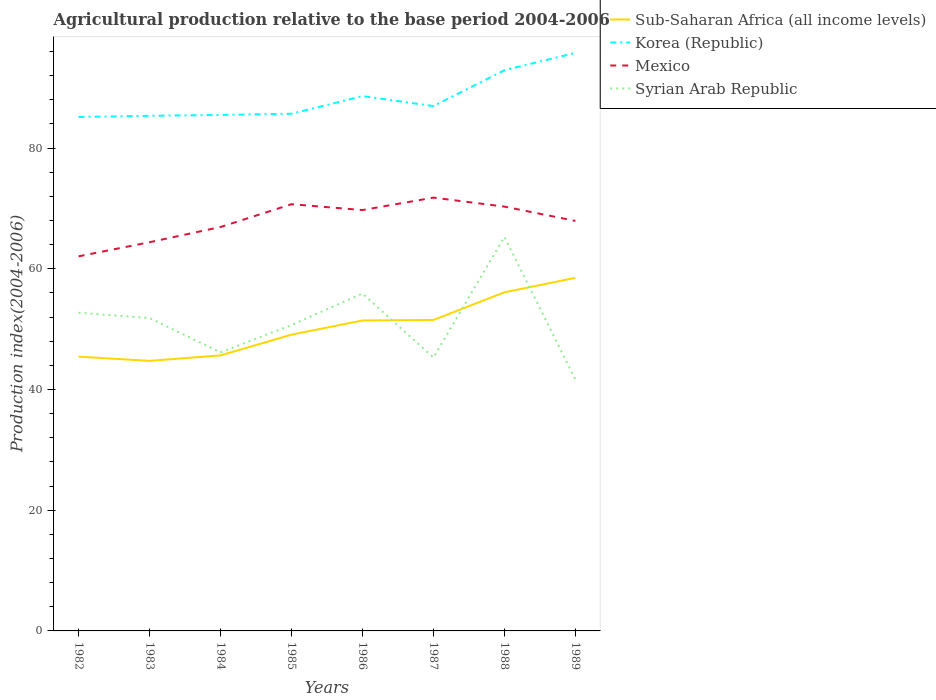Is the number of lines equal to the number of legend labels?
Provide a short and direct response. Yes. Across all years, what is the maximum agricultural production index in Sub-Saharan Africa (all income levels)?
Make the answer very short. 44.75. What is the total agricultural production index in Syrian Arab Republic in the graph?
Your response must be concise. -3.19. What is the difference between the highest and the second highest agricultural production index in Mexico?
Your answer should be compact. 9.73. How many lines are there?
Provide a short and direct response. 4. Does the graph contain any zero values?
Offer a terse response. No. Does the graph contain grids?
Provide a short and direct response. No. How are the legend labels stacked?
Make the answer very short. Vertical. What is the title of the graph?
Provide a short and direct response. Agricultural production relative to the base period 2004-2006. What is the label or title of the Y-axis?
Your answer should be compact. Production index(2004-2006). What is the Production index(2004-2006) in Sub-Saharan Africa (all income levels) in 1982?
Offer a very short reply. 45.45. What is the Production index(2004-2006) of Korea (Republic) in 1982?
Keep it short and to the point. 85.16. What is the Production index(2004-2006) of Mexico in 1982?
Your answer should be very brief. 62.07. What is the Production index(2004-2006) of Syrian Arab Republic in 1982?
Make the answer very short. 52.72. What is the Production index(2004-2006) in Sub-Saharan Africa (all income levels) in 1983?
Your answer should be compact. 44.75. What is the Production index(2004-2006) in Korea (Republic) in 1983?
Provide a succinct answer. 85.36. What is the Production index(2004-2006) in Mexico in 1983?
Provide a short and direct response. 64.41. What is the Production index(2004-2006) of Syrian Arab Republic in 1983?
Offer a terse response. 51.85. What is the Production index(2004-2006) of Sub-Saharan Africa (all income levels) in 1984?
Keep it short and to the point. 45.66. What is the Production index(2004-2006) of Korea (Republic) in 1984?
Your response must be concise. 85.5. What is the Production index(2004-2006) in Mexico in 1984?
Provide a short and direct response. 66.93. What is the Production index(2004-2006) in Syrian Arab Republic in 1984?
Your answer should be very brief. 46.16. What is the Production index(2004-2006) in Sub-Saharan Africa (all income levels) in 1985?
Your answer should be compact. 49.09. What is the Production index(2004-2006) in Korea (Republic) in 1985?
Make the answer very short. 85.7. What is the Production index(2004-2006) in Mexico in 1985?
Offer a terse response. 70.71. What is the Production index(2004-2006) of Syrian Arab Republic in 1985?
Your answer should be compact. 50.69. What is the Production index(2004-2006) of Sub-Saharan Africa (all income levels) in 1986?
Your answer should be compact. 51.44. What is the Production index(2004-2006) of Korea (Republic) in 1986?
Provide a short and direct response. 88.62. What is the Production index(2004-2006) in Mexico in 1986?
Your response must be concise. 69.74. What is the Production index(2004-2006) in Syrian Arab Republic in 1986?
Offer a very short reply. 55.91. What is the Production index(2004-2006) in Sub-Saharan Africa (all income levels) in 1987?
Offer a very short reply. 51.53. What is the Production index(2004-2006) in Korea (Republic) in 1987?
Provide a succinct answer. 86.97. What is the Production index(2004-2006) in Mexico in 1987?
Offer a very short reply. 71.8. What is the Production index(2004-2006) of Syrian Arab Republic in 1987?
Ensure brevity in your answer.  45.3. What is the Production index(2004-2006) of Sub-Saharan Africa (all income levels) in 1988?
Your response must be concise. 56.11. What is the Production index(2004-2006) of Korea (Republic) in 1988?
Offer a terse response. 92.91. What is the Production index(2004-2006) in Mexico in 1988?
Your answer should be compact. 70.31. What is the Production index(2004-2006) of Syrian Arab Republic in 1988?
Give a very brief answer. 65.29. What is the Production index(2004-2006) of Sub-Saharan Africa (all income levels) in 1989?
Provide a short and direct response. 58.51. What is the Production index(2004-2006) of Korea (Republic) in 1989?
Your answer should be compact. 95.78. What is the Production index(2004-2006) of Mexico in 1989?
Offer a very short reply. 67.94. What is the Production index(2004-2006) in Syrian Arab Republic in 1989?
Your answer should be very brief. 41.65. Across all years, what is the maximum Production index(2004-2006) of Sub-Saharan Africa (all income levels)?
Provide a short and direct response. 58.51. Across all years, what is the maximum Production index(2004-2006) of Korea (Republic)?
Give a very brief answer. 95.78. Across all years, what is the maximum Production index(2004-2006) in Mexico?
Provide a short and direct response. 71.8. Across all years, what is the maximum Production index(2004-2006) of Syrian Arab Republic?
Your response must be concise. 65.29. Across all years, what is the minimum Production index(2004-2006) of Sub-Saharan Africa (all income levels)?
Ensure brevity in your answer.  44.75. Across all years, what is the minimum Production index(2004-2006) in Korea (Republic)?
Make the answer very short. 85.16. Across all years, what is the minimum Production index(2004-2006) in Mexico?
Offer a very short reply. 62.07. Across all years, what is the minimum Production index(2004-2006) in Syrian Arab Republic?
Provide a succinct answer. 41.65. What is the total Production index(2004-2006) in Sub-Saharan Africa (all income levels) in the graph?
Your response must be concise. 402.54. What is the total Production index(2004-2006) of Korea (Republic) in the graph?
Ensure brevity in your answer.  706. What is the total Production index(2004-2006) of Mexico in the graph?
Give a very brief answer. 543.91. What is the total Production index(2004-2006) in Syrian Arab Republic in the graph?
Your response must be concise. 409.57. What is the difference between the Production index(2004-2006) in Sub-Saharan Africa (all income levels) in 1982 and that in 1983?
Provide a short and direct response. 0.7. What is the difference between the Production index(2004-2006) of Korea (Republic) in 1982 and that in 1983?
Offer a terse response. -0.2. What is the difference between the Production index(2004-2006) of Mexico in 1982 and that in 1983?
Your response must be concise. -2.34. What is the difference between the Production index(2004-2006) of Syrian Arab Republic in 1982 and that in 1983?
Ensure brevity in your answer.  0.87. What is the difference between the Production index(2004-2006) in Sub-Saharan Africa (all income levels) in 1982 and that in 1984?
Give a very brief answer. -0.2. What is the difference between the Production index(2004-2006) of Korea (Republic) in 1982 and that in 1984?
Your answer should be very brief. -0.34. What is the difference between the Production index(2004-2006) in Mexico in 1982 and that in 1984?
Your answer should be compact. -4.86. What is the difference between the Production index(2004-2006) in Syrian Arab Republic in 1982 and that in 1984?
Your answer should be compact. 6.56. What is the difference between the Production index(2004-2006) in Sub-Saharan Africa (all income levels) in 1982 and that in 1985?
Your answer should be compact. -3.64. What is the difference between the Production index(2004-2006) of Korea (Republic) in 1982 and that in 1985?
Your answer should be very brief. -0.54. What is the difference between the Production index(2004-2006) of Mexico in 1982 and that in 1985?
Offer a very short reply. -8.64. What is the difference between the Production index(2004-2006) of Syrian Arab Republic in 1982 and that in 1985?
Ensure brevity in your answer.  2.03. What is the difference between the Production index(2004-2006) in Sub-Saharan Africa (all income levels) in 1982 and that in 1986?
Offer a terse response. -5.99. What is the difference between the Production index(2004-2006) of Korea (Republic) in 1982 and that in 1986?
Offer a terse response. -3.46. What is the difference between the Production index(2004-2006) in Mexico in 1982 and that in 1986?
Offer a very short reply. -7.67. What is the difference between the Production index(2004-2006) of Syrian Arab Republic in 1982 and that in 1986?
Your answer should be very brief. -3.19. What is the difference between the Production index(2004-2006) of Sub-Saharan Africa (all income levels) in 1982 and that in 1987?
Make the answer very short. -6.08. What is the difference between the Production index(2004-2006) of Korea (Republic) in 1982 and that in 1987?
Your answer should be very brief. -1.81. What is the difference between the Production index(2004-2006) in Mexico in 1982 and that in 1987?
Offer a very short reply. -9.73. What is the difference between the Production index(2004-2006) in Syrian Arab Republic in 1982 and that in 1987?
Your answer should be very brief. 7.42. What is the difference between the Production index(2004-2006) of Sub-Saharan Africa (all income levels) in 1982 and that in 1988?
Keep it short and to the point. -10.66. What is the difference between the Production index(2004-2006) of Korea (Republic) in 1982 and that in 1988?
Your answer should be compact. -7.75. What is the difference between the Production index(2004-2006) of Mexico in 1982 and that in 1988?
Make the answer very short. -8.24. What is the difference between the Production index(2004-2006) of Syrian Arab Republic in 1982 and that in 1988?
Provide a succinct answer. -12.57. What is the difference between the Production index(2004-2006) in Sub-Saharan Africa (all income levels) in 1982 and that in 1989?
Your answer should be very brief. -13.06. What is the difference between the Production index(2004-2006) of Korea (Republic) in 1982 and that in 1989?
Offer a very short reply. -10.62. What is the difference between the Production index(2004-2006) in Mexico in 1982 and that in 1989?
Ensure brevity in your answer.  -5.87. What is the difference between the Production index(2004-2006) in Syrian Arab Republic in 1982 and that in 1989?
Offer a terse response. 11.07. What is the difference between the Production index(2004-2006) in Sub-Saharan Africa (all income levels) in 1983 and that in 1984?
Give a very brief answer. -0.91. What is the difference between the Production index(2004-2006) in Korea (Republic) in 1983 and that in 1984?
Offer a terse response. -0.14. What is the difference between the Production index(2004-2006) of Mexico in 1983 and that in 1984?
Your answer should be compact. -2.52. What is the difference between the Production index(2004-2006) in Syrian Arab Republic in 1983 and that in 1984?
Offer a terse response. 5.69. What is the difference between the Production index(2004-2006) in Sub-Saharan Africa (all income levels) in 1983 and that in 1985?
Make the answer very short. -4.34. What is the difference between the Production index(2004-2006) in Korea (Republic) in 1983 and that in 1985?
Offer a terse response. -0.34. What is the difference between the Production index(2004-2006) of Mexico in 1983 and that in 1985?
Provide a succinct answer. -6.3. What is the difference between the Production index(2004-2006) in Syrian Arab Republic in 1983 and that in 1985?
Offer a terse response. 1.16. What is the difference between the Production index(2004-2006) in Sub-Saharan Africa (all income levels) in 1983 and that in 1986?
Offer a very short reply. -6.69. What is the difference between the Production index(2004-2006) of Korea (Republic) in 1983 and that in 1986?
Provide a short and direct response. -3.26. What is the difference between the Production index(2004-2006) in Mexico in 1983 and that in 1986?
Offer a very short reply. -5.33. What is the difference between the Production index(2004-2006) in Syrian Arab Republic in 1983 and that in 1986?
Offer a terse response. -4.06. What is the difference between the Production index(2004-2006) in Sub-Saharan Africa (all income levels) in 1983 and that in 1987?
Your response must be concise. -6.78. What is the difference between the Production index(2004-2006) of Korea (Republic) in 1983 and that in 1987?
Ensure brevity in your answer.  -1.61. What is the difference between the Production index(2004-2006) in Mexico in 1983 and that in 1987?
Keep it short and to the point. -7.39. What is the difference between the Production index(2004-2006) of Syrian Arab Republic in 1983 and that in 1987?
Your response must be concise. 6.55. What is the difference between the Production index(2004-2006) of Sub-Saharan Africa (all income levels) in 1983 and that in 1988?
Provide a succinct answer. -11.36. What is the difference between the Production index(2004-2006) in Korea (Republic) in 1983 and that in 1988?
Your response must be concise. -7.55. What is the difference between the Production index(2004-2006) in Syrian Arab Republic in 1983 and that in 1988?
Your answer should be very brief. -13.44. What is the difference between the Production index(2004-2006) in Sub-Saharan Africa (all income levels) in 1983 and that in 1989?
Your response must be concise. -13.76. What is the difference between the Production index(2004-2006) in Korea (Republic) in 1983 and that in 1989?
Your response must be concise. -10.42. What is the difference between the Production index(2004-2006) in Mexico in 1983 and that in 1989?
Your answer should be compact. -3.53. What is the difference between the Production index(2004-2006) in Syrian Arab Republic in 1983 and that in 1989?
Provide a short and direct response. 10.2. What is the difference between the Production index(2004-2006) in Sub-Saharan Africa (all income levels) in 1984 and that in 1985?
Your answer should be compact. -3.44. What is the difference between the Production index(2004-2006) in Mexico in 1984 and that in 1985?
Offer a terse response. -3.78. What is the difference between the Production index(2004-2006) of Syrian Arab Republic in 1984 and that in 1985?
Your answer should be very brief. -4.53. What is the difference between the Production index(2004-2006) in Sub-Saharan Africa (all income levels) in 1984 and that in 1986?
Provide a short and direct response. -5.79. What is the difference between the Production index(2004-2006) of Korea (Republic) in 1984 and that in 1986?
Make the answer very short. -3.12. What is the difference between the Production index(2004-2006) of Mexico in 1984 and that in 1986?
Ensure brevity in your answer.  -2.81. What is the difference between the Production index(2004-2006) in Syrian Arab Republic in 1984 and that in 1986?
Offer a terse response. -9.75. What is the difference between the Production index(2004-2006) in Sub-Saharan Africa (all income levels) in 1984 and that in 1987?
Keep it short and to the point. -5.87. What is the difference between the Production index(2004-2006) of Korea (Republic) in 1984 and that in 1987?
Ensure brevity in your answer.  -1.47. What is the difference between the Production index(2004-2006) in Mexico in 1984 and that in 1987?
Your answer should be very brief. -4.87. What is the difference between the Production index(2004-2006) in Syrian Arab Republic in 1984 and that in 1987?
Make the answer very short. 0.86. What is the difference between the Production index(2004-2006) of Sub-Saharan Africa (all income levels) in 1984 and that in 1988?
Provide a succinct answer. -10.45. What is the difference between the Production index(2004-2006) of Korea (Republic) in 1984 and that in 1988?
Your answer should be compact. -7.41. What is the difference between the Production index(2004-2006) in Mexico in 1984 and that in 1988?
Your response must be concise. -3.38. What is the difference between the Production index(2004-2006) in Syrian Arab Republic in 1984 and that in 1988?
Your response must be concise. -19.13. What is the difference between the Production index(2004-2006) in Sub-Saharan Africa (all income levels) in 1984 and that in 1989?
Give a very brief answer. -12.86. What is the difference between the Production index(2004-2006) of Korea (Republic) in 1984 and that in 1989?
Provide a succinct answer. -10.28. What is the difference between the Production index(2004-2006) in Mexico in 1984 and that in 1989?
Offer a terse response. -1.01. What is the difference between the Production index(2004-2006) of Syrian Arab Republic in 1984 and that in 1989?
Provide a succinct answer. 4.51. What is the difference between the Production index(2004-2006) in Sub-Saharan Africa (all income levels) in 1985 and that in 1986?
Ensure brevity in your answer.  -2.35. What is the difference between the Production index(2004-2006) in Korea (Republic) in 1985 and that in 1986?
Keep it short and to the point. -2.92. What is the difference between the Production index(2004-2006) of Syrian Arab Republic in 1985 and that in 1986?
Your answer should be very brief. -5.22. What is the difference between the Production index(2004-2006) in Sub-Saharan Africa (all income levels) in 1985 and that in 1987?
Provide a short and direct response. -2.43. What is the difference between the Production index(2004-2006) in Korea (Republic) in 1985 and that in 1987?
Keep it short and to the point. -1.27. What is the difference between the Production index(2004-2006) in Mexico in 1985 and that in 1987?
Provide a short and direct response. -1.09. What is the difference between the Production index(2004-2006) in Syrian Arab Republic in 1985 and that in 1987?
Offer a terse response. 5.39. What is the difference between the Production index(2004-2006) of Sub-Saharan Africa (all income levels) in 1985 and that in 1988?
Your response must be concise. -7.02. What is the difference between the Production index(2004-2006) of Korea (Republic) in 1985 and that in 1988?
Offer a very short reply. -7.21. What is the difference between the Production index(2004-2006) of Syrian Arab Republic in 1985 and that in 1988?
Give a very brief answer. -14.6. What is the difference between the Production index(2004-2006) of Sub-Saharan Africa (all income levels) in 1985 and that in 1989?
Your response must be concise. -9.42. What is the difference between the Production index(2004-2006) in Korea (Republic) in 1985 and that in 1989?
Make the answer very short. -10.08. What is the difference between the Production index(2004-2006) in Mexico in 1985 and that in 1989?
Your response must be concise. 2.77. What is the difference between the Production index(2004-2006) of Syrian Arab Republic in 1985 and that in 1989?
Keep it short and to the point. 9.04. What is the difference between the Production index(2004-2006) in Sub-Saharan Africa (all income levels) in 1986 and that in 1987?
Give a very brief answer. -0.08. What is the difference between the Production index(2004-2006) of Korea (Republic) in 1986 and that in 1987?
Ensure brevity in your answer.  1.65. What is the difference between the Production index(2004-2006) in Mexico in 1986 and that in 1987?
Provide a short and direct response. -2.06. What is the difference between the Production index(2004-2006) in Syrian Arab Republic in 1986 and that in 1987?
Your answer should be very brief. 10.61. What is the difference between the Production index(2004-2006) in Sub-Saharan Africa (all income levels) in 1986 and that in 1988?
Your answer should be compact. -4.67. What is the difference between the Production index(2004-2006) of Korea (Republic) in 1986 and that in 1988?
Ensure brevity in your answer.  -4.29. What is the difference between the Production index(2004-2006) of Mexico in 1986 and that in 1988?
Keep it short and to the point. -0.57. What is the difference between the Production index(2004-2006) of Syrian Arab Republic in 1986 and that in 1988?
Keep it short and to the point. -9.38. What is the difference between the Production index(2004-2006) of Sub-Saharan Africa (all income levels) in 1986 and that in 1989?
Your answer should be compact. -7.07. What is the difference between the Production index(2004-2006) of Korea (Republic) in 1986 and that in 1989?
Your response must be concise. -7.16. What is the difference between the Production index(2004-2006) of Syrian Arab Republic in 1986 and that in 1989?
Make the answer very short. 14.26. What is the difference between the Production index(2004-2006) in Sub-Saharan Africa (all income levels) in 1987 and that in 1988?
Your answer should be very brief. -4.58. What is the difference between the Production index(2004-2006) in Korea (Republic) in 1987 and that in 1988?
Keep it short and to the point. -5.94. What is the difference between the Production index(2004-2006) of Mexico in 1987 and that in 1988?
Ensure brevity in your answer.  1.49. What is the difference between the Production index(2004-2006) of Syrian Arab Republic in 1987 and that in 1988?
Offer a terse response. -19.99. What is the difference between the Production index(2004-2006) in Sub-Saharan Africa (all income levels) in 1987 and that in 1989?
Your answer should be very brief. -6.99. What is the difference between the Production index(2004-2006) in Korea (Republic) in 1987 and that in 1989?
Your response must be concise. -8.81. What is the difference between the Production index(2004-2006) of Mexico in 1987 and that in 1989?
Your answer should be compact. 3.86. What is the difference between the Production index(2004-2006) in Syrian Arab Republic in 1987 and that in 1989?
Offer a very short reply. 3.65. What is the difference between the Production index(2004-2006) in Sub-Saharan Africa (all income levels) in 1988 and that in 1989?
Provide a succinct answer. -2.4. What is the difference between the Production index(2004-2006) in Korea (Republic) in 1988 and that in 1989?
Provide a succinct answer. -2.87. What is the difference between the Production index(2004-2006) in Mexico in 1988 and that in 1989?
Give a very brief answer. 2.37. What is the difference between the Production index(2004-2006) of Syrian Arab Republic in 1988 and that in 1989?
Provide a short and direct response. 23.64. What is the difference between the Production index(2004-2006) of Sub-Saharan Africa (all income levels) in 1982 and the Production index(2004-2006) of Korea (Republic) in 1983?
Offer a very short reply. -39.91. What is the difference between the Production index(2004-2006) of Sub-Saharan Africa (all income levels) in 1982 and the Production index(2004-2006) of Mexico in 1983?
Keep it short and to the point. -18.96. What is the difference between the Production index(2004-2006) of Sub-Saharan Africa (all income levels) in 1982 and the Production index(2004-2006) of Syrian Arab Republic in 1983?
Keep it short and to the point. -6.4. What is the difference between the Production index(2004-2006) in Korea (Republic) in 1982 and the Production index(2004-2006) in Mexico in 1983?
Offer a very short reply. 20.75. What is the difference between the Production index(2004-2006) of Korea (Republic) in 1982 and the Production index(2004-2006) of Syrian Arab Republic in 1983?
Provide a succinct answer. 33.31. What is the difference between the Production index(2004-2006) in Mexico in 1982 and the Production index(2004-2006) in Syrian Arab Republic in 1983?
Your response must be concise. 10.22. What is the difference between the Production index(2004-2006) of Sub-Saharan Africa (all income levels) in 1982 and the Production index(2004-2006) of Korea (Republic) in 1984?
Provide a succinct answer. -40.05. What is the difference between the Production index(2004-2006) of Sub-Saharan Africa (all income levels) in 1982 and the Production index(2004-2006) of Mexico in 1984?
Provide a short and direct response. -21.48. What is the difference between the Production index(2004-2006) in Sub-Saharan Africa (all income levels) in 1982 and the Production index(2004-2006) in Syrian Arab Republic in 1984?
Provide a short and direct response. -0.71. What is the difference between the Production index(2004-2006) of Korea (Republic) in 1982 and the Production index(2004-2006) of Mexico in 1984?
Your response must be concise. 18.23. What is the difference between the Production index(2004-2006) in Mexico in 1982 and the Production index(2004-2006) in Syrian Arab Republic in 1984?
Provide a succinct answer. 15.91. What is the difference between the Production index(2004-2006) in Sub-Saharan Africa (all income levels) in 1982 and the Production index(2004-2006) in Korea (Republic) in 1985?
Provide a succinct answer. -40.25. What is the difference between the Production index(2004-2006) of Sub-Saharan Africa (all income levels) in 1982 and the Production index(2004-2006) of Mexico in 1985?
Ensure brevity in your answer.  -25.26. What is the difference between the Production index(2004-2006) in Sub-Saharan Africa (all income levels) in 1982 and the Production index(2004-2006) in Syrian Arab Republic in 1985?
Provide a succinct answer. -5.24. What is the difference between the Production index(2004-2006) of Korea (Republic) in 1982 and the Production index(2004-2006) of Mexico in 1985?
Your answer should be compact. 14.45. What is the difference between the Production index(2004-2006) of Korea (Republic) in 1982 and the Production index(2004-2006) of Syrian Arab Republic in 1985?
Provide a succinct answer. 34.47. What is the difference between the Production index(2004-2006) of Mexico in 1982 and the Production index(2004-2006) of Syrian Arab Republic in 1985?
Your response must be concise. 11.38. What is the difference between the Production index(2004-2006) in Sub-Saharan Africa (all income levels) in 1982 and the Production index(2004-2006) in Korea (Republic) in 1986?
Provide a short and direct response. -43.17. What is the difference between the Production index(2004-2006) in Sub-Saharan Africa (all income levels) in 1982 and the Production index(2004-2006) in Mexico in 1986?
Offer a terse response. -24.29. What is the difference between the Production index(2004-2006) in Sub-Saharan Africa (all income levels) in 1982 and the Production index(2004-2006) in Syrian Arab Republic in 1986?
Your response must be concise. -10.46. What is the difference between the Production index(2004-2006) of Korea (Republic) in 1982 and the Production index(2004-2006) of Mexico in 1986?
Keep it short and to the point. 15.42. What is the difference between the Production index(2004-2006) of Korea (Republic) in 1982 and the Production index(2004-2006) of Syrian Arab Republic in 1986?
Make the answer very short. 29.25. What is the difference between the Production index(2004-2006) in Mexico in 1982 and the Production index(2004-2006) in Syrian Arab Republic in 1986?
Your answer should be very brief. 6.16. What is the difference between the Production index(2004-2006) of Sub-Saharan Africa (all income levels) in 1982 and the Production index(2004-2006) of Korea (Republic) in 1987?
Give a very brief answer. -41.52. What is the difference between the Production index(2004-2006) of Sub-Saharan Africa (all income levels) in 1982 and the Production index(2004-2006) of Mexico in 1987?
Your response must be concise. -26.35. What is the difference between the Production index(2004-2006) of Sub-Saharan Africa (all income levels) in 1982 and the Production index(2004-2006) of Syrian Arab Republic in 1987?
Offer a terse response. 0.15. What is the difference between the Production index(2004-2006) in Korea (Republic) in 1982 and the Production index(2004-2006) in Mexico in 1987?
Make the answer very short. 13.36. What is the difference between the Production index(2004-2006) of Korea (Republic) in 1982 and the Production index(2004-2006) of Syrian Arab Republic in 1987?
Offer a terse response. 39.86. What is the difference between the Production index(2004-2006) in Mexico in 1982 and the Production index(2004-2006) in Syrian Arab Republic in 1987?
Your answer should be compact. 16.77. What is the difference between the Production index(2004-2006) in Sub-Saharan Africa (all income levels) in 1982 and the Production index(2004-2006) in Korea (Republic) in 1988?
Your response must be concise. -47.46. What is the difference between the Production index(2004-2006) in Sub-Saharan Africa (all income levels) in 1982 and the Production index(2004-2006) in Mexico in 1988?
Your answer should be compact. -24.86. What is the difference between the Production index(2004-2006) in Sub-Saharan Africa (all income levels) in 1982 and the Production index(2004-2006) in Syrian Arab Republic in 1988?
Your answer should be very brief. -19.84. What is the difference between the Production index(2004-2006) in Korea (Republic) in 1982 and the Production index(2004-2006) in Mexico in 1988?
Offer a terse response. 14.85. What is the difference between the Production index(2004-2006) of Korea (Republic) in 1982 and the Production index(2004-2006) of Syrian Arab Republic in 1988?
Your response must be concise. 19.87. What is the difference between the Production index(2004-2006) in Mexico in 1982 and the Production index(2004-2006) in Syrian Arab Republic in 1988?
Your answer should be very brief. -3.22. What is the difference between the Production index(2004-2006) of Sub-Saharan Africa (all income levels) in 1982 and the Production index(2004-2006) of Korea (Republic) in 1989?
Ensure brevity in your answer.  -50.33. What is the difference between the Production index(2004-2006) in Sub-Saharan Africa (all income levels) in 1982 and the Production index(2004-2006) in Mexico in 1989?
Offer a very short reply. -22.49. What is the difference between the Production index(2004-2006) in Sub-Saharan Africa (all income levels) in 1982 and the Production index(2004-2006) in Syrian Arab Republic in 1989?
Provide a succinct answer. 3.8. What is the difference between the Production index(2004-2006) of Korea (Republic) in 1982 and the Production index(2004-2006) of Mexico in 1989?
Keep it short and to the point. 17.22. What is the difference between the Production index(2004-2006) of Korea (Republic) in 1982 and the Production index(2004-2006) of Syrian Arab Republic in 1989?
Provide a short and direct response. 43.51. What is the difference between the Production index(2004-2006) of Mexico in 1982 and the Production index(2004-2006) of Syrian Arab Republic in 1989?
Provide a succinct answer. 20.42. What is the difference between the Production index(2004-2006) in Sub-Saharan Africa (all income levels) in 1983 and the Production index(2004-2006) in Korea (Republic) in 1984?
Your answer should be very brief. -40.75. What is the difference between the Production index(2004-2006) in Sub-Saharan Africa (all income levels) in 1983 and the Production index(2004-2006) in Mexico in 1984?
Offer a very short reply. -22.18. What is the difference between the Production index(2004-2006) of Sub-Saharan Africa (all income levels) in 1983 and the Production index(2004-2006) of Syrian Arab Republic in 1984?
Offer a terse response. -1.41. What is the difference between the Production index(2004-2006) in Korea (Republic) in 1983 and the Production index(2004-2006) in Mexico in 1984?
Your answer should be compact. 18.43. What is the difference between the Production index(2004-2006) in Korea (Republic) in 1983 and the Production index(2004-2006) in Syrian Arab Republic in 1984?
Keep it short and to the point. 39.2. What is the difference between the Production index(2004-2006) of Mexico in 1983 and the Production index(2004-2006) of Syrian Arab Republic in 1984?
Offer a very short reply. 18.25. What is the difference between the Production index(2004-2006) in Sub-Saharan Africa (all income levels) in 1983 and the Production index(2004-2006) in Korea (Republic) in 1985?
Provide a short and direct response. -40.95. What is the difference between the Production index(2004-2006) of Sub-Saharan Africa (all income levels) in 1983 and the Production index(2004-2006) of Mexico in 1985?
Your answer should be compact. -25.96. What is the difference between the Production index(2004-2006) of Sub-Saharan Africa (all income levels) in 1983 and the Production index(2004-2006) of Syrian Arab Republic in 1985?
Provide a short and direct response. -5.94. What is the difference between the Production index(2004-2006) in Korea (Republic) in 1983 and the Production index(2004-2006) in Mexico in 1985?
Your answer should be compact. 14.65. What is the difference between the Production index(2004-2006) in Korea (Republic) in 1983 and the Production index(2004-2006) in Syrian Arab Republic in 1985?
Make the answer very short. 34.67. What is the difference between the Production index(2004-2006) in Mexico in 1983 and the Production index(2004-2006) in Syrian Arab Republic in 1985?
Offer a terse response. 13.72. What is the difference between the Production index(2004-2006) of Sub-Saharan Africa (all income levels) in 1983 and the Production index(2004-2006) of Korea (Republic) in 1986?
Your response must be concise. -43.87. What is the difference between the Production index(2004-2006) of Sub-Saharan Africa (all income levels) in 1983 and the Production index(2004-2006) of Mexico in 1986?
Provide a short and direct response. -24.99. What is the difference between the Production index(2004-2006) of Sub-Saharan Africa (all income levels) in 1983 and the Production index(2004-2006) of Syrian Arab Republic in 1986?
Provide a succinct answer. -11.16. What is the difference between the Production index(2004-2006) in Korea (Republic) in 1983 and the Production index(2004-2006) in Mexico in 1986?
Ensure brevity in your answer.  15.62. What is the difference between the Production index(2004-2006) of Korea (Republic) in 1983 and the Production index(2004-2006) of Syrian Arab Republic in 1986?
Give a very brief answer. 29.45. What is the difference between the Production index(2004-2006) of Sub-Saharan Africa (all income levels) in 1983 and the Production index(2004-2006) of Korea (Republic) in 1987?
Provide a short and direct response. -42.22. What is the difference between the Production index(2004-2006) of Sub-Saharan Africa (all income levels) in 1983 and the Production index(2004-2006) of Mexico in 1987?
Give a very brief answer. -27.05. What is the difference between the Production index(2004-2006) of Sub-Saharan Africa (all income levels) in 1983 and the Production index(2004-2006) of Syrian Arab Republic in 1987?
Your answer should be compact. -0.55. What is the difference between the Production index(2004-2006) in Korea (Republic) in 1983 and the Production index(2004-2006) in Mexico in 1987?
Your response must be concise. 13.56. What is the difference between the Production index(2004-2006) of Korea (Republic) in 1983 and the Production index(2004-2006) of Syrian Arab Republic in 1987?
Your response must be concise. 40.06. What is the difference between the Production index(2004-2006) in Mexico in 1983 and the Production index(2004-2006) in Syrian Arab Republic in 1987?
Offer a terse response. 19.11. What is the difference between the Production index(2004-2006) in Sub-Saharan Africa (all income levels) in 1983 and the Production index(2004-2006) in Korea (Republic) in 1988?
Offer a terse response. -48.16. What is the difference between the Production index(2004-2006) of Sub-Saharan Africa (all income levels) in 1983 and the Production index(2004-2006) of Mexico in 1988?
Keep it short and to the point. -25.56. What is the difference between the Production index(2004-2006) in Sub-Saharan Africa (all income levels) in 1983 and the Production index(2004-2006) in Syrian Arab Republic in 1988?
Your answer should be compact. -20.54. What is the difference between the Production index(2004-2006) in Korea (Republic) in 1983 and the Production index(2004-2006) in Mexico in 1988?
Offer a very short reply. 15.05. What is the difference between the Production index(2004-2006) in Korea (Republic) in 1983 and the Production index(2004-2006) in Syrian Arab Republic in 1988?
Provide a succinct answer. 20.07. What is the difference between the Production index(2004-2006) of Mexico in 1983 and the Production index(2004-2006) of Syrian Arab Republic in 1988?
Keep it short and to the point. -0.88. What is the difference between the Production index(2004-2006) of Sub-Saharan Africa (all income levels) in 1983 and the Production index(2004-2006) of Korea (Republic) in 1989?
Offer a terse response. -51.03. What is the difference between the Production index(2004-2006) of Sub-Saharan Africa (all income levels) in 1983 and the Production index(2004-2006) of Mexico in 1989?
Your answer should be very brief. -23.19. What is the difference between the Production index(2004-2006) in Sub-Saharan Africa (all income levels) in 1983 and the Production index(2004-2006) in Syrian Arab Republic in 1989?
Your answer should be compact. 3.1. What is the difference between the Production index(2004-2006) of Korea (Republic) in 1983 and the Production index(2004-2006) of Mexico in 1989?
Your answer should be compact. 17.42. What is the difference between the Production index(2004-2006) of Korea (Republic) in 1983 and the Production index(2004-2006) of Syrian Arab Republic in 1989?
Your answer should be compact. 43.71. What is the difference between the Production index(2004-2006) of Mexico in 1983 and the Production index(2004-2006) of Syrian Arab Republic in 1989?
Give a very brief answer. 22.76. What is the difference between the Production index(2004-2006) of Sub-Saharan Africa (all income levels) in 1984 and the Production index(2004-2006) of Korea (Republic) in 1985?
Provide a succinct answer. -40.04. What is the difference between the Production index(2004-2006) in Sub-Saharan Africa (all income levels) in 1984 and the Production index(2004-2006) in Mexico in 1985?
Keep it short and to the point. -25.05. What is the difference between the Production index(2004-2006) of Sub-Saharan Africa (all income levels) in 1984 and the Production index(2004-2006) of Syrian Arab Republic in 1985?
Offer a terse response. -5.03. What is the difference between the Production index(2004-2006) in Korea (Republic) in 1984 and the Production index(2004-2006) in Mexico in 1985?
Give a very brief answer. 14.79. What is the difference between the Production index(2004-2006) in Korea (Republic) in 1984 and the Production index(2004-2006) in Syrian Arab Republic in 1985?
Keep it short and to the point. 34.81. What is the difference between the Production index(2004-2006) in Mexico in 1984 and the Production index(2004-2006) in Syrian Arab Republic in 1985?
Offer a very short reply. 16.24. What is the difference between the Production index(2004-2006) of Sub-Saharan Africa (all income levels) in 1984 and the Production index(2004-2006) of Korea (Republic) in 1986?
Ensure brevity in your answer.  -42.96. What is the difference between the Production index(2004-2006) of Sub-Saharan Africa (all income levels) in 1984 and the Production index(2004-2006) of Mexico in 1986?
Provide a succinct answer. -24.08. What is the difference between the Production index(2004-2006) in Sub-Saharan Africa (all income levels) in 1984 and the Production index(2004-2006) in Syrian Arab Republic in 1986?
Your response must be concise. -10.25. What is the difference between the Production index(2004-2006) of Korea (Republic) in 1984 and the Production index(2004-2006) of Mexico in 1986?
Your answer should be compact. 15.76. What is the difference between the Production index(2004-2006) in Korea (Republic) in 1984 and the Production index(2004-2006) in Syrian Arab Republic in 1986?
Offer a terse response. 29.59. What is the difference between the Production index(2004-2006) of Mexico in 1984 and the Production index(2004-2006) of Syrian Arab Republic in 1986?
Give a very brief answer. 11.02. What is the difference between the Production index(2004-2006) of Sub-Saharan Africa (all income levels) in 1984 and the Production index(2004-2006) of Korea (Republic) in 1987?
Keep it short and to the point. -41.31. What is the difference between the Production index(2004-2006) in Sub-Saharan Africa (all income levels) in 1984 and the Production index(2004-2006) in Mexico in 1987?
Your answer should be compact. -26.14. What is the difference between the Production index(2004-2006) in Sub-Saharan Africa (all income levels) in 1984 and the Production index(2004-2006) in Syrian Arab Republic in 1987?
Make the answer very short. 0.36. What is the difference between the Production index(2004-2006) in Korea (Republic) in 1984 and the Production index(2004-2006) in Syrian Arab Republic in 1987?
Keep it short and to the point. 40.2. What is the difference between the Production index(2004-2006) in Mexico in 1984 and the Production index(2004-2006) in Syrian Arab Republic in 1987?
Give a very brief answer. 21.63. What is the difference between the Production index(2004-2006) of Sub-Saharan Africa (all income levels) in 1984 and the Production index(2004-2006) of Korea (Republic) in 1988?
Your response must be concise. -47.25. What is the difference between the Production index(2004-2006) of Sub-Saharan Africa (all income levels) in 1984 and the Production index(2004-2006) of Mexico in 1988?
Ensure brevity in your answer.  -24.65. What is the difference between the Production index(2004-2006) of Sub-Saharan Africa (all income levels) in 1984 and the Production index(2004-2006) of Syrian Arab Republic in 1988?
Offer a terse response. -19.63. What is the difference between the Production index(2004-2006) of Korea (Republic) in 1984 and the Production index(2004-2006) of Mexico in 1988?
Offer a very short reply. 15.19. What is the difference between the Production index(2004-2006) of Korea (Republic) in 1984 and the Production index(2004-2006) of Syrian Arab Republic in 1988?
Offer a terse response. 20.21. What is the difference between the Production index(2004-2006) in Mexico in 1984 and the Production index(2004-2006) in Syrian Arab Republic in 1988?
Your response must be concise. 1.64. What is the difference between the Production index(2004-2006) of Sub-Saharan Africa (all income levels) in 1984 and the Production index(2004-2006) of Korea (Republic) in 1989?
Provide a short and direct response. -50.12. What is the difference between the Production index(2004-2006) of Sub-Saharan Africa (all income levels) in 1984 and the Production index(2004-2006) of Mexico in 1989?
Make the answer very short. -22.28. What is the difference between the Production index(2004-2006) of Sub-Saharan Africa (all income levels) in 1984 and the Production index(2004-2006) of Syrian Arab Republic in 1989?
Your answer should be compact. 4.01. What is the difference between the Production index(2004-2006) in Korea (Republic) in 1984 and the Production index(2004-2006) in Mexico in 1989?
Provide a short and direct response. 17.56. What is the difference between the Production index(2004-2006) of Korea (Republic) in 1984 and the Production index(2004-2006) of Syrian Arab Republic in 1989?
Provide a short and direct response. 43.85. What is the difference between the Production index(2004-2006) of Mexico in 1984 and the Production index(2004-2006) of Syrian Arab Republic in 1989?
Give a very brief answer. 25.28. What is the difference between the Production index(2004-2006) in Sub-Saharan Africa (all income levels) in 1985 and the Production index(2004-2006) in Korea (Republic) in 1986?
Offer a very short reply. -39.53. What is the difference between the Production index(2004-2006) in Sub-Saharan Africa (all income levels) in 1985 and the Production index(2004-2006) in Mexico in 1986?
Provide a short and direct response. -20.65. What is the difference between the Production index(2004-2006) of Sub-Saharan Africa (all income levels) in 1985 and the Production index(2004-2006) of Syrian Arab Republic in 1986?
Provide a succinct answer. -6.82. What is the difference between the Production index(2004-2006) in Korea (Republic) in 1985 and the Production index(2004-2006) in Mexico in 1986?
Provide a short and direct response. 15.96. What is the difference between the Production index(2004-2006) of Korea (Republic) in 1985 and the Production index(2004-2006) of Syrian Arab Republic in 1986?
Make the answer very short. 29.79. What is the difference between the Production index(2004-2006) of Mexico in 1985 and the Production index(2004-2006) of Syrian Arab Republic in 1986?
Your answer should be very brief. 14.8. What is the difference between the Production index(2004-2006) of Sub-Saharan Africa (all income levels) in 1985 and the Production index(2004-2006) of Korea (Republic) in 1987?
Make the answer very short. -37.88. What is the difference between the Production index(2004-2006) in Sub-Saharan Africa (all income levels) in 1985 and the Production index(2004-2006) in Mexico in 1987?
Give a very brief answer. -22.71. What is the difference between the Production index(2004-2006) in Sub-Saharan Africa (all income levels) in 1985 and the Production index(2004-2006) in Syrian Arab Republic in 1987?
Provide a succinct answer. 3.79. What is the difference between the Production index(2004-2006) in Korea (Republic) in 1985 and the Production index(2004-2006) in Mexico in 1987?
Your answer should be compact. 13.9. What is the difference between the Production index(2004-2006) of Korea (Republic) in 1985 and the Production index(2004-2006) of Syrian Arab Republic in 1987?
Provide a short and direct response. 40.4. What is the difference between the Production index(2004-2006) of Mexico in 1985 and the Production index(2004-2006) of Syrian Arab Republic in 1987?
Provide a short and direct response. 25.41. What is the difference between the Production index(2004-2006) in Sub-Saharan Africa (all income levels) in 1985 and the Production index(2004-2006) in Korea (Republic) in 1988?
Provide a short and direct response. -43.82. What is the difference between the Production index(2004-2006) of Sub-Saharan Africa (all income levels) in 1985 and the Production index(2004-2006) of Mexico in 1988?
Your answer should be compact. -21.22. What is the difference between the Production index(2004-2006) of Sub-Saharan Africa (all income levels) in 1985 and the Production index(2004-2006) of Syrian Arab Republic in 1988?
Offer a terse response. -16.2. What is the difference between the Production index(2004-2006) in Korea (Republic) in 1985 and the Production index(2004-2006) in Mexico in 1988?
Make the answer very short. 15.39. What is the difference between the Production index(2004-2006) in Korea (Republic) in 1985 and the Production index(2004-2006) in Syrian Arab Republic in 1988?
Offer a very short reply. 20.41. What is the difference between the Production index(2004-2006) of Mexico in 1985 and the Production index(2004-2006) of Syrian Arab Republic in 1988?
Provide a short and direct response. 5.42. What is the difference between the Production index(2004-2006) of Sub-Saharan Africa (all income levels) in 1985 and the Production index(2004-2006) of Korea (Republic) in 1989?
Give a very brief answer. -46.69. What is the difference between the Production index(2004-2006) of Sub-Saharan Africa (all income levels) in 1985 and the Production index(2004-2006) of Mexico in 1989?
Offer a very short reply. -18.85. What is the difference between the Production index(2004-2006) of Sub-Saharan Africa (all income levels) in 1985 and the Production index(2004-2006) of Syrian Arab Republic in 1989?
Ensure brevity in your answer.  7.44. What is the difference between the Production index(2004-2006) in Korea (Republic) in 1985 and the Production index(2004-2006) in Mexico in 1989?
Your answer should be very brief. 17.76. What is the difference between the Production index(2004-2006) in Korea (Republic) in 1985 and the Production index(2004-2006) in Syrian Arab Republic in 1989?
Make the answer very short. 44.05. What is the difference between the Production index(2004-2006) in Mexico in 1985 and the Production index(2004-2006) in Syrian Arab Republic in 1989?
Provide a short and direct response. 29.06. What is the difference between the Production index(2004-2006) in Sub-Saharan Africa (all income levels) in 1986 and the Production index(2004-2006) in Korea (Republic) in 1987?
Your response must be concise. -35.53. What is the difference between the Production index(2004-2006) in Sub-Saharan Africa (all income levels) in 1986 and the Production index(2004-2006) in Mexico in 1987?
Make the answer very short. -20.36. What is the difference between the Production index(2004-2006) of Sub-Saharan Africa (all income levels) in 1986 and the Production index(2004-2006) of Syrian Arab Republic in 1987?
Your response must be concise. 6.14. What is the difference between the Production index(2004-2006) in Korea (Republic) in 1986 and the Production index(2004-2006) in Mexico in 1987?
Offer a very short reply. 16.82. What is the difference between the Production index(2004-2006) of Korea (Republic) in 1986 and the Production index(2004-2006) of Syrian Arab Republic in 1987?
Ensure brevity in your answer.  43.32. What is the difference between the Production index(2004-2006) in Mexico in 1986 and the Production index(2004-2006) in Syrian Arab Republic in 1987?
Offer a very short reply. 24.44. What is the difference between the Production index(2004-2006) of Sub-Saharan Africa (all income levels) in 1986 and the Production index(2004-2006) of Korea (Republic) in 1988?
Offer a very short reply. -41.47. What is the difference between the Production index(2004-2006) of Sub-Saharan Africa (all income levels) in 1986 and the Production index(2004-2006) of Mexico in 1988?
Your answer should be compact. -18.87. What is the difference between the Production index(2004-2006) of Sub-Saharan Africa (all income levels) in 1986 and the Production index(2004-2006) of Syrian Arab Republic in 1988?
Your answer should be compact. -13.85. What is the difference between the Production index(2004-2006) of Korea (Republic) in 1986 and the Production index(2004-2006) of Mexico in 1988?
Offer a very short reply. 18.31. What is the difference between the Production index(2004-2006) in Korea (Republic) in 1986 and the Production index(2004-2006) in Syrian Arab Republic in 1988?
Offer a terse response. 23.33. What is the difference between the Production index(2004-2006) in Mexico in 1986 and the Production index(2004-2006) in Syrian Arab Republic in 1988?
Provide a succinct answer. 4.45. What is the difference between the Production index(2004-2006) in Sub-Saharan Africa (all income levels) in 1986 and the Production index(2004-2006) in Korea (Republic) in 1989?
Provide a succinct answer. -44.34. What is the difference between the Production index(2004-2006) in Sub-Saharan Africa (all income levels) in 1986 and the Production index(2004-2006) in Mexico in 1989?
Provide a short and direct response. -16.5. What is the difference between the Production index(2004-2006) of Sub-Saharan Africa (all income levels) in 1986 and the Production index(2004-2006) of Syrian Arab Republic in 1989?
Provide a short and direct response. 9.79. What is the difference between the Production index(2004-2006) in Korea (Republic) in 1986 and the Production index(2004-2006) in Mexico in 1989?
Give a very brief answer. 20.68. What is the difference between the Production index(2004-2006) of Korea (Republic) in 1986 and the Production index(2004-2006) of Syrian Arab Republic in 1989?
Provide a succinct answer. 46.97. What is the difference between the Production index(2004-2006) in Mexico in 1986 and the Production index(2004-2006) in Syrian Arab Republic in 1989?
Offer a terse response. 28.09. What is the difference between the Production index(2004-2006) in Sub-Saharan Africa (all income levels) in 1987 and the Production index(2004-2006) in Korea (Republic) in 1988?
Your answer should be very brief. -41.38. What is the difference between the Production index(2004-2006) in Sub-Saharan Africa (all income levels) in 1987 and the Production index(2004-2006) in Mexico in 1988?
Ensure brevity in your answer.  -18.78. What is the difference between the Production index(2004-2006) of Sub-Saharan Africa (all income levels) in 1987 and the Production index(2004-2006) of Syrian Arab Republic in 1988?
Make the answer very short. -13.76. What is the difference between the Production index(2004-2006) in Korea (Republic) in 1987 and the Production index(2004-2006) in Mexico in 1988?
Offer a very short reply. 16.66. What is the difference between the Production index(2004-2006) in Korea (Republic) in 1987 and the Production index(2004-2006) in Syrian Arab Republic in 1988?
Offer a terse response. 21.68. What is the difference between the Production index(2004-2006) in Mexico in 1987 and the Production index(2004-2006) in Syrian Arab Republic in 1988?
Your answer should be very brief. 6.51. What is the difference between the Production index(2004-2006) in Sub-Saharan Africa (all income levels) in 1987 and the Production index(2004-2006) in Korea (Republic) in 1989?
Give a very brief answer. -44.25. What is the difference between the Production index(2004-2006) of Sub-Saharan Africa (all income levels) in 1987 and the Production index(2004-2006) of Mexico in 1989?
Offer a very short reply. -16.41. What is the difference between the Production index(2004-2006) in Sub-Saharan Africa (all income levels) in 1987 and the Production index(2004-2006) in Syrian Arab Republic in 1989?
Keep it short and to the point. 9.88. What is the difference between the Production index(2004-2006) in Korea (Republic) in 1987 and the Production index(2004-2006) in Mexico in 1989?
Your response must be concise. 19.03. What is the difference between the Production index(2004-2006) in Korea (Republic) in 1987 and the Production index(2004-2006) in Syrian Arab Republic in 1989?
Provide a succinct answer. 45.32. What is the difference between the Production index(2004-2006) in Mexico in 1987 and the Production index(2004-2006) in Syrian Arab Republic in 1989?
Your answer should be very brief. 30.15. What is the difference between the Production index(2004-2006) in Sub-Saharan Africa (all income levels) in 1988 and the Production index(2004-2006) in Korea (Republic) in 1989?
Your response must be concise. -39.67. What is the difference between the Production index(2004-2006) of Sub-Saharan Africa (all income levels) in 1988 and the Production index(2004-2006) of Mexico in 1989?
Provide a short and direct response. -11.83. What is the difference between the Production index(2004-2006) in Sub-Saharan Africa (all income levels) in 1988 and the Production index(2004-2006) in Syrian Arab Republic in 1989?
Your answer should be very brief. 14.46. What is the difference between the Production index(2004-2006) of Korea (Republic) in 1988 and the Production index(2004-2006) of Mexico in 1989?
Give a very brief answer. 24.97. What is the difference between the Production index(2004-2006) of Korea (Republic) in 1988 and the Production index(2004-2006) of Syrian Arab Republic in 1989?
Your answer should be very brief. 51.26. What is the difference between the Production index(2004-2006) of Mexico in 1988 and the Production index(2004-2006) of Syrian Arab Republic in 1989?
Your answer should be very brief. 28.66. What is the average Production index(2004-2006) in Sub-Saharan Africa (all income levels) per year?
Offer a very short reply. 50.32. What is the average Production index(2004-2006) of Korea (Republic) per year?
Give a very brief answer. 88.25. What is the average Production index(2004-2006) of Mexico per year?
Provide a succinct answer. 67.99. What is the average Production index(2004-2006) of Syrian Arab Republic per year?
Your answer should be compact. 51.2. In the year 1982, what is the difference between the Production index(2004-2006) of Sub-Saharan Africa (all income levels) and Production index(2004-2006) of Korea (Republic)?
Offer a very short reply. -39.71. In the year 1982, what is the difference between the Production index(2004-2006) of Sub-Saharan Africa (all income levels) and Production index(2004-2006) of Mexico?
Your answer should be compact. -16.62. In the year 1982, what is the difference between the Production index(2004-2006) of Sub-Saharan Africa (all income levels) and Production index(2004-2006) of Syrian Arab Republic?
Offer a very short reply. -7.27. In the year 1982, what is the difference between the Production index(2004-2006) of Korea (Republic) and Production index(2004-2006) of Mexico?
Offer a very short reply. 23.09. In the year 1982, what is the difference between the Production index(2004-2006) in Korea (Republic) and Production index(2004-2006) in Syrian Arab Republic?
Your answer should be very brief. 32.44. In the year 1982, what is the difference between the Production index(2004-2006) in Mexico and Production index(2004-2006) in Syrian Arab Republic?
Offer a terse response. 9.35. In the year 1983, what is the difference between the Production index(2004-2006) in Sub-Saharan Africa (all income levels) and Production index(2004-2006) in Korea (Republic)?
Ensure brevity in your answer.  -40.61. In the year 1983, what is the difference between the Production index(2004-2006) in Sub-Saharan Africa (all income levels) and Production index(2004-2006) in Mexico?
Your answer should be compact. -19.66. In the year 1983, what is the difference between the Production index(2004-2006) in Sub-Saharan Africa (all income levels) and Production index(2004-2006) in Syrian Arab Republic?
Your response must be concise. -7.1. In the year 1983, what is the difference between the Production index(2004-2006) of Korea (Republic) and Production index(2004-2006) of Mexico?
Your answer should be compact. 20.95. In the year 1983, what is the difference between the Production index(2004-2006) in Korea (Republic) and Production index(2004-2006) in Syrian Arab Republic?
Offer a terse response. 33.51. In the year 1983, what is the difference between the Production index(2004-2006) in Mexico and Production index(2004-2006) in Syrian Arab Republic?
Make the answer very short. 12.56. In the year 1984, what is the difference between the Production index(2004-2006) in Sub-Saharan Africa (all income levels) and Production index(2004-2006) in Korea (Republic)?
Make the answer very short. -39.84. In the year 1984, what is the difference between the Production index(2004-2006) in Sub-Saharan Africa (all income levels) and Production index(2004-2006) in Mexico?
Provide a succinct answer. -21.27. In the year 1984, what is the difference between the Production index(2004-2006) of Sub-Saharan Africa (all income levels) and Production index(2004-2006) of Syrian Arab Republic?
Keep it short and to the point. -0.5. In the year 1984, what is the difference between the Production index(2004-2006) of Korea (Republic) and Production index(2004-2006) of Mexico?
Offer a terse response. 18.57. In the year 1984, what is the difference between the Production index(2004-2006) of Korea (Republic) and Production index(2004-2006) of Syrian Arab Republic?
Offer a very short reply. 39.34. In the year 1984, what is the difference between the Production index(2004-2006) in Mexico and Production index(2004-2006) in Syrian Arab Republic?
Offer a very short reply. 20.77. In the year 1985, what is the difference between the Production index(2004-2006) in Sub-Saharan Africa (all income levels) and Production index(2004-2006) in Korea (Republic)?
Provide a succinct answer. -36.61. In the year 1985, what is the difference between the Production index(2004-2006) in Sub-Saharan Africa (all income levels) and Production index(2004-2006) in Mexico?
Ensure brevity in your answer.  -21.62. In the year 1985, what is the difference between the Production index(2004-2006) of Sub-Saharan Africa (all income levels) and Production index(2004-2006) of Syrian Arab Republic?
Ensure brevity in your answer.  -1.6. In the year 1985, what is the difference between the Production index(2004-2006) of Korea (Republic) and Production index(2004-2006) of Mexico?
Offer a very short reply. 14.99. In the year 1985, what is the difference between the Production index(2004-2006) in Korea (Republic) and Production index(2004-2006) in Syrian Arab Republic?
Your answer should be compact. 35.01. In the year 1985, what is the difference between the Production index(2004-2006) in Mexico and Production index(2004-2006) in Syrian Arab Republic?
Provide a short and direct response. 20.02. In the year 1986, what is the difference between the Production index(2004-2006) in Sub-Saharan Africa (all income levels) and Production index(2004-2006) in Korea (Republic)?
Your answer should be compact. -37.18. In the year 1986, what is the difference between the Production index(2004-2006) of Sub-Saharan Africa (all income levels) and Production index(2004-2006) of Mexico?
Your response must be concise. -18.3. In the year 1986, what is the difference between the Production index(2004-2006) in Sub-Saharan Africa (all income levels) and Production index(2004-2006) in Syrian Arab Republic?
Make the answer very short. -4.47. In the year 1986, what is the difference between the Production index(2004-2006) in Korea (Republic) and Production index(2004-2006) in Mexico?
Keep it short and to the point. 18.88. In the year 1986, what is the difference between the Production index(2004-2006) of Korea (Republic) and Production index(2004-2006) of Syrian Arab Republic?
Ensure brevity in your answer.  32.71. In the year 1986, what is the difference between the Production index(2004-2006) of Mexico and Production index(2004-2006) of Syrian Arab Republic?
Offer a very short reply. 13.83. In the year 1987, what is the difference between the Production index(2004-2006) of Sub-Saharan Africa (all income levels) and Production index(2004-2006) of Korea (Republic)?
Offer a very short reply. -35.44. In the year 1987, what is the difference between the Production index(2004-2006) of Sub-Saharan Africa (all income levels) and Production index(2004-2006) of Mexico?
Provide a short and direct response. -20.27. In the year 1987, what is the difference between the Production index(2004-2006) of Sub-Saharan Africa (all income levels) and Production index(2004-2006) of Syrian Arab Republic?
Offer a very short reply. 6.23. In the year 1987, what is the difference between the Production index(2004-2006) of Korea (Republic) and Production index(2004-2006) of Mexico?
Make the answer very short. 15.17. In the year 1987, what is the difference between the Production index(2004-2006) in Korea (Republic) and Production index(2004-2006) in Syrian Arab Republic?
Offer a terse response. 41.67. In the year 1988, what is the difference between the Production index(2004-2006) of Sub-Saharan Africa (all income levels) and Production index(2004-2006) of Korea (Republic)?
Ensure brevity in your answer.  -36.8. In the year 1988, what is the difference between the Production index(2004-2006) in Sub-Saharan Africa (all income levels) and Production index(2004-2006) in Mexico?
Provide a succinct answer. -14.2. In the year 1988, what is the difference between the Production index(2004-2006) of Sub-Saharan Africa (all income levels) and Production index(2004-2006) of Syrian Arab Republic?
Provide a succinct answer. -9.18. In the year 1988, what is the difference between the Production index(2004-2006) of Korea (Republic) and Production index(2004-2006) of Mexico?
Give a very brief answer. 22.6. In the year 1988, what is the difference between the Production index(2004-2006) of Korea (Republic) and Production index(2004-2006) of Syrian Arab Republic?
Make the answer very short. 27.62. In the year 1988, what is the difference between the Production index(2004-2006) of Mexico and Production index(2004-2006) of Syrian Arab Republic?
Your answer should be very brief. 5.02. In the year 1989, what is the difference between the Production index(2004-2006) of Sub-Saharan Africa (all income levels) and Production index(2004-2006) of Korea (Republic)?
Your response must be concise. -37.27. In the year 1989, what is the difference between the Production index(2004-2006) of Sub-Saharan Africa (all income levels) and Production index(2004-2006) of Mexico?
Offer a terse response. -9.43. In the year 1989, what is the difference between the Production index(2004-2006) in Sub-Saharan Africa (all income levels) and Production index(2004-2006) in Syrian Arab Republic?
Your answer should be very brief. 16.86. In the year 1989, what is the difference between the Production index(2004-2006) of Korea (Republic) and Production index(2004-2006) of Mexico?
Your answer should be compact. 27.84. In the year 1989, what is the difference between the Production index(2004-2006) in Korea (Republic) and Production index(2004-2006) in Syrian Arab Republic?
Provide a short and direct response. 54.13. In the year 1989, what is the difference between the Production index(2004-2006) in Mexico and Production index(2004-2006) in Syrian Arab Republic?
Your answer should be compact. 26.29. What is the ratio of the Production index(2004-2006) of Sub-Saharan Africa (all income levels) in 1982 to that in 1983?
Provide a short and direct response. 1.02. What is the ratio of the Production index(2004-2006) of Mexico in 1982 to that in 1983?
Your answer should be compact. 0.96. What is the ratio of the Production index(2004-2006) of Syrian Arab Republic in 1982 to that in 1983?
Provide a short and direct response. 1.02. What is the ratio of the Production index(2004-2006) in Mexico in 1982 to that in 1984?
Provide a succinct answer. 0.93. What is the ratio of the Production index(2004-2006) in Syrian Arab Republic in 1982 to that in 1984?
Provide a succinct answer. 1.14. What is the ratio of the Production index(2004-2006) of Sub-Saharan Africa (all income levels) in 1982 to that in 1985?
Provide a succinct answer. 0.93. What is the ratio of the Production index(2004-2006) in Mexico in 1982 to that in 1985?
Your answer should be very brief. 0.88. What is the ratio of the Production index(2004-2006) in Sub-Saharan Africa (all income levels) in 1982 to that in 1986?
Offer a very short reply. 0.88. What is the ratio of the Production index(2004-2006) of Mexico in 1982 to that in 1986?
Ensure brevity in your answer.  0.89. What is the ratio of the Production index(2004-2006) of Syrian Arab Republic in 1982 to that in 1986?
Offer a very short reply. 0.94. What is the ratio of the Production index(2004-2006) of Sub-Saharan Africa (all income levels) in 1982 to that in 1987?
Ensure brevity in your answer.  0.88. What is the ratio of the Production index(2004-2006) of Korea (Republic) in 1982 to that in 1987?
Make the answer very short. 0.98. What is the ratio of the Production index(2004-2006) in Mexico in 1982 to that in 1987?
Your answer should be compact. 0.86. What is the ratio of the Production index(2004-2006) of Syrian Arab Republic in 1982 to that in 1987?
Your answer should be compact. 1.16. What is the ratio of the Production index(2004-2006) in Sub-Saharan Africa (all income levels) in 1982 to that in 1988?
Ensure brevity in your answer.  0.81. What is the ratio of the Production index(2004-2006) of Korea (Republic) in 1982 to that in 1988?
Your answer should be very brief. 0.92. What is the ratio of the Production index(2004-2006) of Mexico in 1982 to that in 1988?
Your response must be concise. 0.88. What is the ratio of the Production index(2004-2006) in Syrian Arab Republic in 1982 to that in 1988?
Ensure brevity in your answer.  0.81. What is the ratio of the Production index(2004-2006) of Sub-Saharan Africa (all income levels) in 1982 to that in 1989?
Keep it short and to the point. 0.78. What is the ratio of the Production index(2004-2006) in Korea (Republic) in 1982 to that in 1989?
Offer a terse response. 0.89. What is the ratio of the Production index(2004-2006) in Mexico in 1982 to that in 1989?
Provide a short and direct response. 0.91. What is the ratio of the Production index(2004-2006) in Syrian Arab Republic in 1982 to that in 1989?
Offer a terse response. 1.27. What is the ratio of the Production index(2004-2006) of Sub-Saharan Africa (all income levels) in 1983 to that in 1984?
Your response must be concise. 0.98. What is the ratio of the Production index(2004-2006) of Korea (Republic) in 1983 to that in 1984?
Offer a very short reply. 1. What is the ratio of the Production index(2004-2006) of Mexico in 1983 to that in 1984?
Provide a short and direct response. 0.96. What is the ratio of the Production index(2004-2006) in Syrian Arab Republic in 1983 to that in 1984?
Offer a very short reply. 1.12. What is the ratio of the Production index(2004-2006) of Sub-Saharan Africa (all income levels) in 1983 to that in 1985?
Ensure brevity in your answer.  0.91. What is the ratio of the Production index(2004-2006) in Mexico in 1983 to that in 1985?
Your answer should be compact. 0.91. What is the ratio of the Production index(2004-2006) of Syrian Arab Republic in 1983 to that in 1985?
Make the answer very short. 1.02. What is the ratio of the Production index(2004-2006) of Sub-Saharan Africa (all income levels) in 1983 to that in 1986?
Your response must be concise. 0.87. What is the ratio of the Production index(2004-2006) of Korea (Republic) in 1983 to that in 1986?
Offer a very short reply. 0.96. What is the ratio of the Production index(2004-2006) in Mexico in 1983 to that in 1986?
Provide a succinct answer. 0.92. What is the ratio of the Production index(2004-2006) of Syrian Arab Republic in 1983 to that in 1986?
Your response must be concise. 0.93. What is the ratio of the Production index(2004-2006) in Sub-Saharan Africa (all income levels) in 1983 to that in 1987?
Give a very brief answer. 0.87. What is the ratio of the Production index(2004-2006) of Korea (Republic) in 1983 to that in 1987?
Provide a short and direct response. 0.98. What is the ratio of the Production index(2004-2006) of Mexico in 1983 to that in 1987?
Make the answer very short. 0.9. What is the ratio of the Production index(2004-2006) in Syrian Arab Republic in 1983 to that in 1987?
Provide a succinct answer. 1.14. What is the ratio of the Production index(2004-2006) of Sub-Saharan Africa (all income levels) in 1983 to that in 1988?
Keep it short and to the point. 0.8. What is the ratio of the Production index(2004-2006) of Korea (Republic) in 1983 to that in 1988?
Your answer should be very brief. 0.92. What is the ratio of the Production index(2004-2006) of Mexico in 1983 to that in 1988?
Provide a short and direct response. 0.92. What is the ratio of the Production index(2004-2006) in Syrian Arab Republic in 1983 to that in 1988?
Your answer should be very brief. 0.79. What is the ratio of the Production index(2004-2006) in Sub-Saharan Africa (all income levels) in 1983 to that in 1989?
Ensure brevity in your answer.  0.76. What is the ratio of the Production index(2004-2006) of Korea (Republic) in 1983 to that in 1989?
Keep it short and to the point. 0.89. What is the ratio of the Production index(2004-2006) of Mexico in 1983 to that in 1989?
Provide a succinct answer. 0.95. What is the ratio of the Production index(2004-2006) in Syrian Arab Republic in 1983 to that in 1989?
Your answer should be very brief. 1.24. What is the ratio of the Production index(2004-2006) in Korea (Republic) in 1984 to that in 1985?
Make the answer very short. 1. What is the ratio of the Production index(2004-2006) in Mexico in 1984 to that in 1985?
Keep it short and to the point. 0.95. What is the ratio of the Production index(2004-2006) of Syrian Arab Republic in 1984 to that in 1985?
Provide a succinct answer. 0.91. What is the ratio of the Production index(2004-2006) of Sub-Saharan Africa (all income levels) in 1984 to that in 1986?
Offer a very short reply. 0.89. What is the ratio of the Production index(2004-2006) of Korea (Republic) in 1984 to that in 1986?
Your answer should be compact. 0.96. What is the ratio of the Production index(2004-2006) in Mexico in 1984 to that in 1986?
Give a very brief answer. 0.96. What is the ratio of the Production index(2004-2006) in Syrian Arab Republic in 1984 to that in 1986?
Make the answer very short. 0.83. What is the ratio of the Production index(2004-2006) in Sub-Saharan Africa (all income levels) in 1984 to that in 1987?
Your answer should be very brief. 0.89. What is the ratio of the Production index(2004-2006) of Korea (Republic) in 1984 to that in 1987?
Offer a terse response. 0.98. What is the ratio of the Production index(2004-2006) of Mexico in 1984 to that in 1987?
Your response must be concise. 0.93. What is the ratio of the Production index(2004-2006) of Syrian Arab Republic in 1984 to that in 1987?
Your answer should be very brief. 1.02. What is the ratio of the Production index(2004-2006) of Sub-Saharan Africa (all income levels) in 1984 to that in 1988?
Your response must be concise. 0.81. What is the ratio of the Production index(2004-2006) in Korea (Republic) in 1984 to that in 1988?
Keep it short and to the point. 0.92. What is the ratio of the Production index(2004-2006) in Mexico in 1984 to that in 1988?
Provide a succinct answer. 0.95. What is the ratio of the Production index(2004-2006) in Syrian Arab Republic in 1984 to that in 1988?
Your response must be concise. 0.71. What is the ratio of the Production index(2004-2006) of Sub-Saharan Africa (all income levels) in 1984 to that in 1989?
Keep it short and to the point. 0.78. What is the ratio of the Production index(2004-2006) in Korea (Republic) in 1984 to that in 1989?
Provide a succinct answer. 0.89. What is the ratio of the Production index(2004-2006) of Mexico in 1984 to that in 1989?
Keep it short and to the point. 0.99. What is the ratio of the Production index(2004-2006) of Syrian Arab Republic in 1984 to that in 1989?
Your answer should be very brief. 1.11. What is the ratio of the Production index(2004-2006) in Sub-Saharan Africa (all income levels) in 1985 to that in 1986?
Provide a succinct answer. 0.95. What is the ratio of the Production index(2004-2006) of Korea (Republic) in 1985 to that in 1986?
Offer a terse response. 0.97. What is the ratio of the Production index(2004-2006) in Mexico in 1985 to that in 1986?
Your response must be concise. 1.01. What is the ratio of the Production index(2004-2006) of Syrian Arab Republic in 1985 to that in 1986?
Keep it short and to the point. 0.91. What is the ratio of the Production index(2004-2006) in Sub-Saharan Africa (all income levels) in 1985 to that in 1987?
Your answer should be compact. 0.95. What is the ratio of the Production index(2004-2006) in Korea (Republic) in 1985 to that in 1987?
Your answer should be compact. 0.99. What is the ratio of the Production index(2004-2006) of Mexico in 1985 to that in 1987?
Keep it short and to the point. 0.98. What is the ratio of the Production index(2004-2006) of Syrian Arab Republic in 1985 to that in 1987?
Provide a succinct answer. 1.12. What is the ratio of the Production index(2004-2006) in Sub-Saharan Africa (all income levels) in 1985 to that in 1988?
Your answer should be compact. 0.88. What is the ratio of the Production index(2004-2006) of Korea (Republic) in 1985 to that in 1988?
Your answer should be very brief. 0.92. What is the ratio of the Production index(2004-2006) in Syrian Arab Republic in 1985 to that in 1988?
Provide a short and direct response. 0.78. What is the ratio of the Production index(2004-2006) in Sub-Saharan Africa (all income levels) in 1985 to that in 1989?
Provide a succinct answer. 0.84. What is the ratio of the Production index(2004-2006) in Korea (Republic) in 1985 to that in 1989?
Provide a short and direct response. 0.89. What is the ratio of the Production index(2004-2006) in Mexico in 1985 to that in 1989?
Offer a very short reply. 1.04. What is the ratio of the Production index(2004-2006) in Syrian Arab Republic in 1985 to that in 1989?
Your answer should be compact. 1.22. What is the ratio of the Production index(2004-2006) in Sub-Saharan Africa (all income levels) in 1986 to that in 1987?
Keep it short and to the point. 1. What is the ratio of the Production index(2004-2006) of Mexico in 1986 to that in 1987?
Your answer should be compact. 0.97. What is the ratio of the Production index(2004-2006) in Syrian Arab Republic in 1986 to that in 1987?
Make the answer very short. 1.23. What is the ratio of the Production index(2004-2006) of Sub-Saharan Africa (all income levels) in 1986 to that in 1988?
Offer a terse response. 0.92. What is the ratio of the Production index(2004-2006) in Korea (Republic) in 1986 to that in 1988?
Offer a terse response. 0.95. What is the ratio of the Production index(2004-2006) in Syrian Arab Republic in 1986 to that in 1988?
Provide a succinct answer. 0.86. What is the ratio of the Production index(2004-2006) of Sub-Saharan Africa (all income levels) in 1986 to that in 1989?
Your response must be concise. 0.88. What is the ratio of the Production index(2004-2006) in Korea (Republic) in 1986 to that in 1989?
Provide a succinct answer. 0.93. What is the ratio of the Production index(2004-2006) of Mexico in 1986 to that in 1989?
Make the answer very short. 1.03. What is the ratio of the Production index(2004-2006) of Syrian Arab Republic in 1986 to that in 1989?
Your answer should be very brief. 1.34. What is the ratio of the Production index(2004-2006) in Sub-Saharan Africa (all income levels) in 1987 to that in 1988?
Your response must be concise. 0.92. What is the ratio of the Production index(2004-2006) of Korea (Republic) in 1987 to that in 1988?
Your response must be concise. 0.94. What is the ratio of the Production index(2004-2006) of Mexico in 1987 to that in 1988?
Provide a succinct answer. 1.02. What is the ratio of the Production index(2004-2006) of Syrian Arab Republic in 1987 to that in 1988?
Keep it short and to the point. 0.69. What is the ratio of the Production index(2004-2006) of Sub-Saharan Africa (all income levels) in 1987 to that in 1989?
Give a very brief answer. 0.88. What is the ratio of the Production index(2004-2006) in Korea (Republic) in 1987 to that in 1989?
Offer a terse response. 0.91. What is the ratio of the Production index(2004-2006) in Mexico in 1987 to that in 1989?
Make the answer very short. 1.06. What is the ratio of the Production index(2004-2006) of Syrian Arab Republic in 1987 to that in 1989?
Keep it short and to the point. 1.09. What is the ratio of the Production index(2004-2006) in Sub-Saharan Africa (all income levels) in 1988 to that in 1989?
Your answer should be compact. 0.96. What is the ratio of the Production index(2004-2006) in Korea (Republic) in 1988 to that in 1989?
Your answer should be very brief. 0.97. What is the ratio of the Production index(2004-2006) of Mexico in 1988 to that in 1989?
Give a very brief answer. 1.03. What is the ratio of the Production index(2004-2006) of Syrian Arab Republic in 1988 to that in 1989?
Your answer should be compact. 1.57. What is the difference between the highest and the second highest Production index(2004-2006) of Sub-Saharan Africa (all income levels)?
Provide a short and direct response. 2.4. What is the difference between the highest and the second highest Production index(2004-2006) of Korea (Republic)?
Make the answer very short. 2.87. What is the difference between the highest and the second highest Production index(2004-2006) in Mexico?
Give a very brief answer. 1.09. What is the difference between the highest and the second highest Production index(2004-2006) in Syrian Arab Republic?
Keep it short and to the point. 9.38. What is the difference between the highest and the lowest Production index(2004-2006) in Sub-Saharan Africa (all income levels)?
Your answer should be compact. 13.76. What is the difference between the highest and the lowest Production index(2004-2006) of Korea (Republic)?
Provide a succinct answer. 10.62. What is the difference between the highest and the lowest Production index(2004-2006) in Mexico?
Ensure brevity in your answer.  9.73. What is the difference between the highest and the lowest Production index(2004-2006) of Syrian Arab Republic?
Your response must be concise. 23.64. 